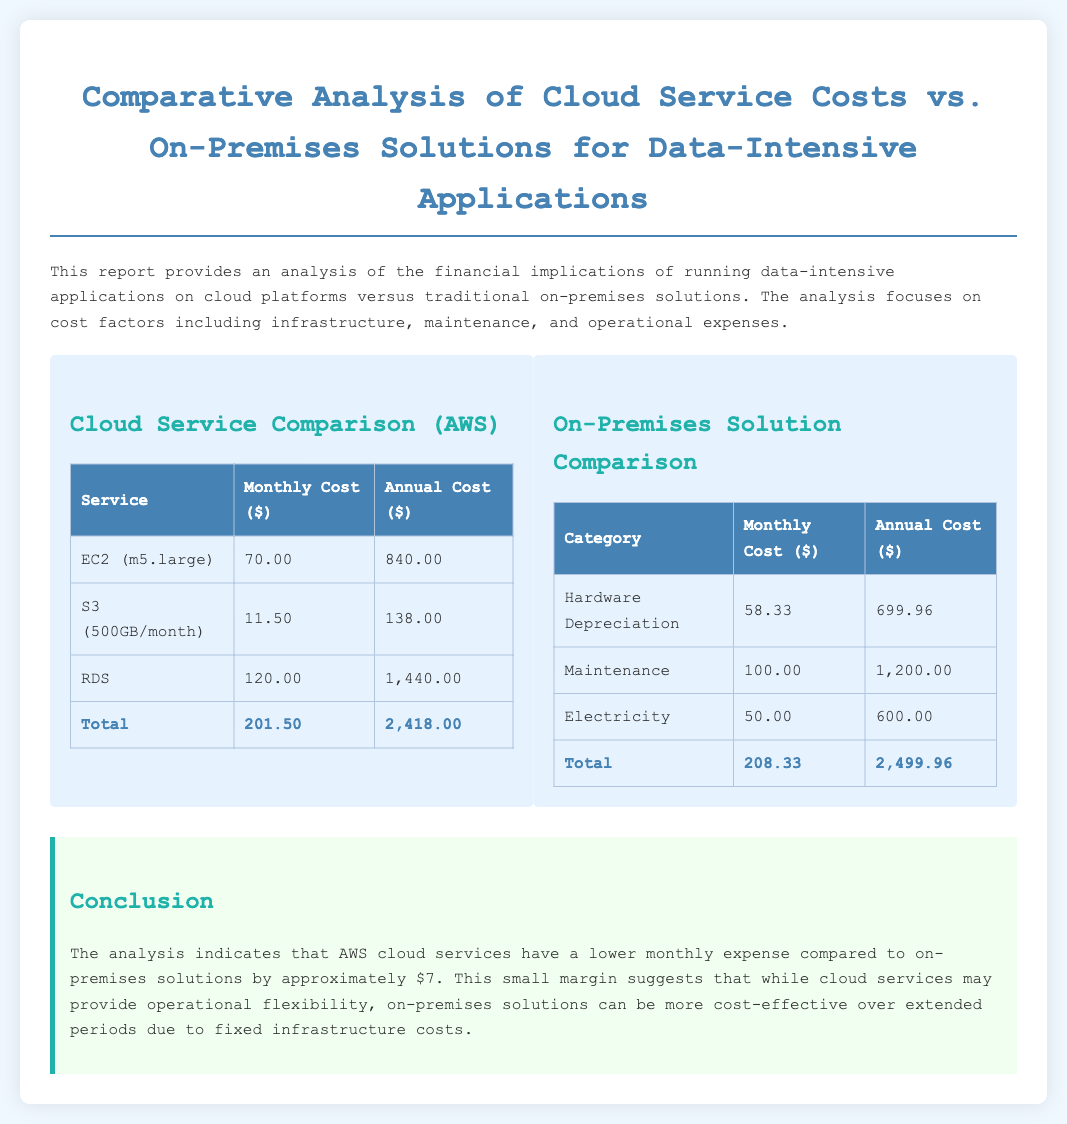what is the monthly cost for EC2 (m5.large)? The monthly cost for EC2 (m5.large) is stated in the cloud service comparison table.
Answer: 70.00 what is the annual cost for S3? The annual cost for S3 is provided in the cloud service comparison table.
Answer: 138.00 what is the total monthly cost for the cloud services? The total monthly cost is calculated by summing the individual monthly costs listed in the cloud service table.
Answer: 201.50 what is the total annual cost for the on-premises solution? The total annual cost is derived from the sum of the annual costs listed in the on-premises solution comparison table.
Answer: 2,499.96 how much lower is the monthly expense for AWS cloud services compared to on-premises solutions? The document states the difference between the total monthly costs of cloud services and on-premises solutions.
Answer: 7.00 what are the categories of costs for on-premises solutions? The on-premises solution section lists the cost categories that contribute to the total costs in that system.
Answer: Hardware Depreciation, Maintenance, Electricity what is the total monthly cost for on-premises solutions? The total monthly cost is calculated by summing the individual monthly costs listed in the on-premises solution table.
Answer: 208.33 what does the conclusion suggest about cloud services versus on-premises solutions? The conclusion summarizes the findings of the report, highlighting the cost-effectiveness over time.
Answer: Operational flexibility versus fixed cost-effectiveness what is the purpose of the report? The document mentions its goal in the introductory paragraph.
Answer: Analysis of financial implications 